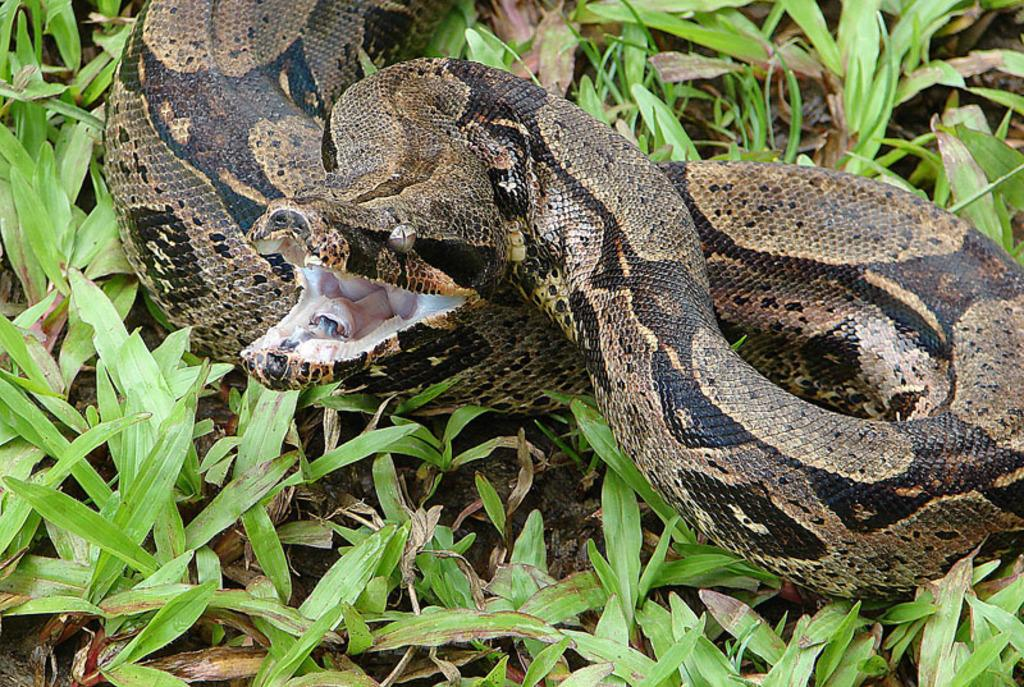What type of animal is in the image? There is a snake in the image. What can be seen beneath the snake? The ground is visible in the image. What else is present in the image besides the snake and the ground? There are plants in the image. What type of addition problem can be solved using the letters in the image? There are no letters present in the image, so it is not possible to solve an addition problem using them. 